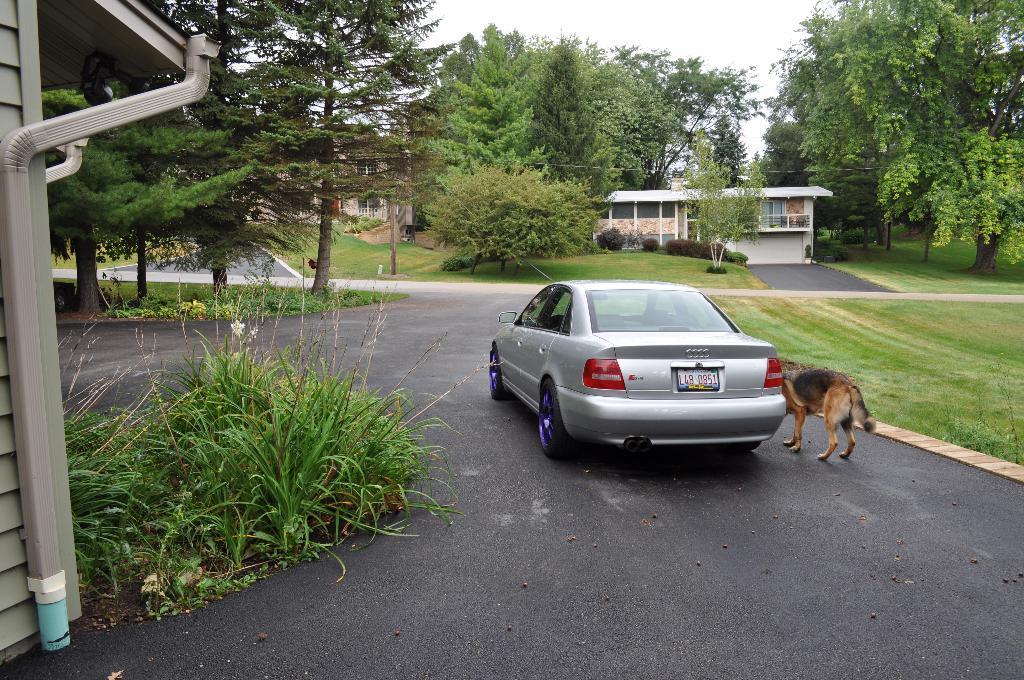Please provide a concise description of this image. This picture shows the buildings and we see trees and a car on the road and we see grass on the ground and few plants and we see a dog. it is black and brown in color and a cloudy Sky. 